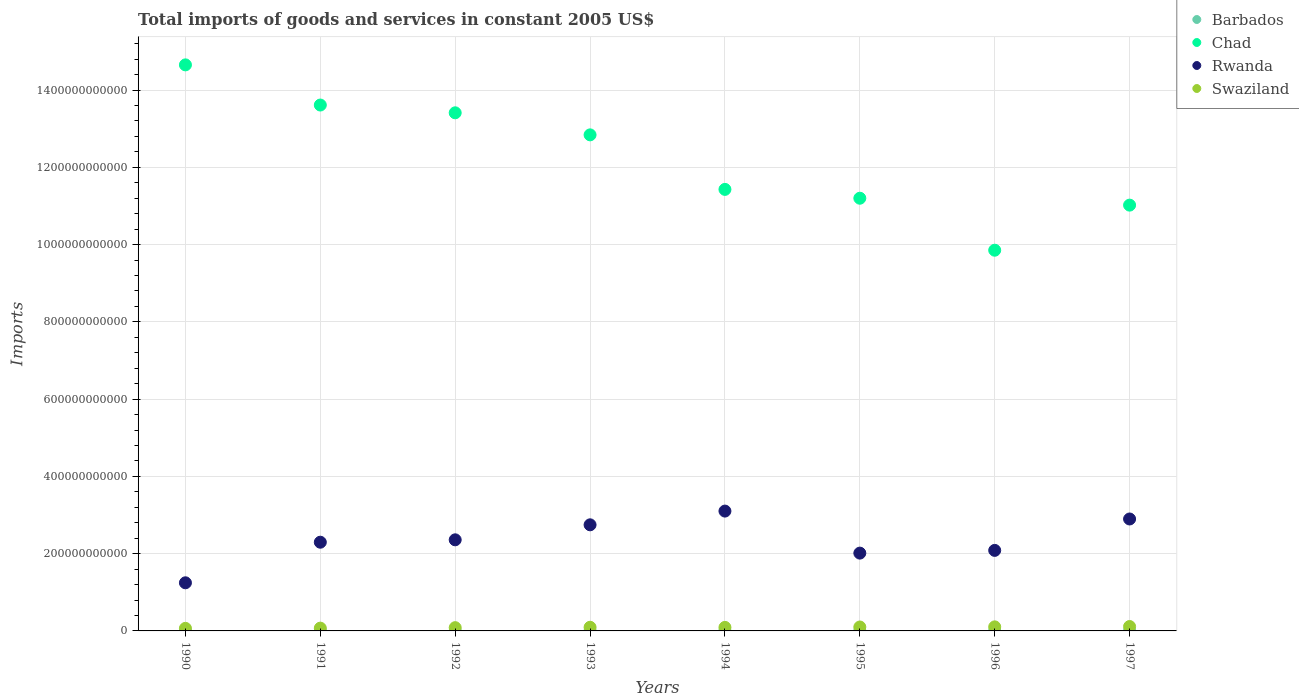Is the number of dotlines equal to the number of legend labels?
Provide a short and direct response. Yes. What is the total imports of goods and services in Chad in 1997?
Ensure brevity in your answer.  1.10e+12. Across all years, what is the maximum total imports of goods and services in Rwanda?
Your answer should be compact. 3.10e+11. Across all years, what is the minimum total imports of goods and services in Rwanda?
Your answer should be very brief. 1.25e+11. In which year was the total imports of goods and services in Chad minimum?
Provide a succinct answer. 1996. What is the total total imports of goods and services in Swaziland in the graph?
Offer a very short reply. 7.30e+1. What is the difference between the total imports of goods and services in Swaziland in 1996 and that in 1997?
Offer a very short reply. -8.96e+08. What is the difference between the total imports of goods and services in Barbados in 1993 and the total imports of goods and services in Swaziland in 1997?
Provide a succinct answer. -1.11e+1. What is the average total imports of goods and services in Swaziland per year?
Your answer should be compact. 9.13e+09. In the year 1991, what is the difference between the total imports of goods and services in Rwanda and total imports of goods and services in Swaziland?
Provide a succinct answer. 2.22e+11. What is the ratio of the total imports of goods and services in Rwanda in 1993 to that in 1995?
Make the answer very short. 1.36. Is the difference between the total imports of goods and services in Rwanda in 1994 and 1996 greater than the difference between the total imports of goods and services in Swaziland in 1994 and 1996?
Provide a succinct answer. Yes. What is the difference between the highest and the second highest total imports of goods and services in Rwanda?
Provide a succinct answer. 2.04e+1. What is the difference between the highest and the lowest total imports of goods and services in Rwanda?
Ensure brevity in your answer.  1.86e+11. In how many years, is the total imports of goods and services in Swaziland greater than the average total imports of goods and services in Swaziland taken over all years?
Keep it short and to the point. 5. Is the sum of the total imports of goods and services in Swaziland in 1993 and 1994 greater than the maximum total imports of goods and services in Rwanda across all years?
Provide a short and direct response. No. Is it the case that in every year, the sum of the total imports of goods and services in Chad and total imports of goods and services in Rwanda  is greater than the sum of total imports of goods and services in Swaziland and total imports of goods and services in Barbados?
Your answer should be compact. Yes. Is it the case that in every year, the sum of the total imports of goods and services in Rwanda and total imports of goods and services in Barbados  is greater than the total imports of goods and services in Swaziland?
Keep it short and to the point. Yes. Does the total imports of goods and services in Rwanda monotonically increase over the years?
Make the answer very short. No. Is the total imports of goods and services in Rwanda strictly greater than the total imports of goods and services in Chad over the years?
Keep it short and to the point. No. How many years are there in the graph?
Offer a terse response. 8. What is the difference between two consecutive major ticks on the Y-axis?
Make the answer very short. 2.00e+11. How many legend labels are there?
Ensure brevity in your answer.  4. What is the title of the graph?
Give a very brief answer. Total imports of goods and services in constant 2005 US$. What is the label or title of the Y-axis?
Provide a short and direct response. Imports. What is the Imports in Barbados in 1990?
Offer a very short reply. 3.87e+08. What is the Imports in Chad in 1990?
Your response must be concise. 1.47e+12. What is the Imports in Rwanda in 1990?
Keep it short and to the point. 1.25e+11. What is the Imports of Swaziland in 1990?
Your answer should be compact. 6.66e+09. What is the Imports in Barbados in 1991?
Your response must be concise. 5.10e+08. What is the Imports in Chad in 1991?
Your response must be concise. 1.36e+12. What is the Imports of Rwanda in 1991?
Ensure brevity in your answer.  2.30e+11. What is the Imports in Swaziland in 1991?
Offer a very short reply. 7.22e+09. What is the Imports of Barbados in 1992?
Offer a very short reply. 2.88e+08. What is the Imports of Chad in 1992?
Your answer should be compact. 1.34e+12. What is the Imports of Rwanda in 1992?
Keep it short and to the point. 2.36e+11. What is the Imports of Swaziland in 1992?
Give a very brief answer. 8.46e+09. What is the Imports of Barbados in 1993?
Your answer should be very brief. 3.28e+08. What is the Imports in Chad in 1993?
Provide a succinct answer. 1.28e+12. What is the Imports in Rwanda in 1993?
Keep it short and to the point. 2.75e+11. What is the Imports in Swaziland in 1993?
Provide a succinct answer. 9.45e+09. What is the Imports in Barbados in 1994?
Make the answer very short. 4.77e+08. What is the Imports in Chad in 1994?
Ensure brevity in your answer.  1.14e+12. What is the Imports of Rwanda in 1994?
Your answer should be compact. 3.10e+11. What is the Imports of Swaziland in 1994?
Your answer should be very brief. 9.14e+09. What is the Imports of Barbados in 1995?
Your answer should be very brief. 5.29e+08. What is the Imports in Chad in 1995?
Your response must be concise. 1.12e+12. What is the Imports of Rwanda in 1995?
Your response must be concise. 2.01e+11. What is the Imports in Swaziland in 1995?
Your answer should be very brief. 1.02e+1. What is the Imports in Barbados in 1996?
Make the answer very short. 5.50e+08. What is the Imports in Chad in 1996?
Your answer should be compact. 9.85e+11. What is the Imports in Rwanda in 1996?
Keep it short and to the point. 2.08e+11. What is the Imports of Swaziland in 1996?
Provide a succinct answer. 1.05e+1. What is the Imports in Barbados in 1997?
Offer a very short reply. 6.80e+08. What is the Imports of Chad in 1997?
Ensure brevity in your answer.  1.10e+12. What is the Imports of Rwanda in 1997?
Provide a short and direct response. 2.90e+11. What is the Imports in Swaziland in 1997?
Your answer should be very brief. 1.14e+1. Across all years, what is the maximum Imports of Barbados?
Ensure brevity in your answer.  6.80e+08. Across all years, what is the maximum Imports of Chad?
Your answer should be compact. 1.47e+12. Across all years, what is the maximum Imports of Rwanda?
Offer a terse response. 3.10e+11. Across all years, what is the maximum Imports of Swaziland?
Ensure brevity in your answer.  1.14e+1. Across all years, what is the minimum Imports of Barbados?
Provide a short and direct response. 2.88e+08. Across all years, what is the minimum Imports of Chad?
Offer a very short reply. 9.85e+11. Across all years, what is the minimum Imports in Rwanda?
Make the answer very short. 1.25e+11. Across all years, what is the minimum Imports in Swaziland?
Your answer should be very brief. 6.66e+09. What is the total Imports of Barbados in the graph?
Make the answer very short. 3.75e+09. What is the total Imports of Chad in the graph?
Give a very brief answer. 9.80e+12. What is the total Imports of Rwanda in the graph?
Your response must be concise. 1.87e+12. What is the total Imports of Swaziland in the graph?
Offer a terse response. 7.30e+1. What is the difference between the Imports of Barbados in 1990 and that in 1991?
Give a very brief answer. -1.23e+08. What is the difference between the Imports of Chad in 1990 and that in 1991?
Your answer should be very brief. 1.04e+11. What is the difference between the Imports in Rwanda in 1990 and that in 1991?
Offer a very short reply. -1.05e+11. What is the difference between the Imports in Swaziland in 1990 and that in 1991?
Offer a terse response. -5.66e+08. What is the difference between the Imports of Barbados in 1990 and that in 1992?
Give a very brief answer. 9.90e+07. What is the difference between the Imports of Chad in 1990 and that in 1992?
Make the answer very short. 1.24e+11. What is the difference between the Imports in Rwanda in 1990 and that in 1992?
Provide a short and direct response. -1.11e+11. What is the difference between the Imports in Swaziland in 1990 and that in 1992?
Your answer should be very brief. -1.80e+09. What is the difference between the Imports in Barbados in 1990 and that in 1993?
Provide a short and direct response. 5.90e+07. What is the difference between the Imports of Chad in 1990 and that in 1993?
Offer a very short reply. 1.81e+11. What is the difference between the Imports of Rwanda in 1990 and that in 1993?
Give a very brief answer. -1.50e+11. What is the difference between the Imports in Swaziland in 1990 and that in 1993?
Provide a short and direct response. -2.79e+09. What is the difference between the Imports in Barbados in 1990 and that in 1994?
Offer a terse response. -9.00e+07. What is the difference between the Imports of Chad in 1990 and that in 1994?
Keep it short and to the point. 3.22e+11. What is the difference between the Imports in Rwanda in 1990 and that in 1994?
Your answer should be compact. -1.86e+11. What is the difference between the Imports of Swaziland in 1990 and that in 1994?
Provide a short and direct response. -2.48e+09. What is the difference between the Imports of Barbados in 1990 and that in 1995?
Offer a terse response. -1.42e+08. What is the difference between the Imports in Chad in 1990 and that in 1995?
Offer a terse response. 3.45e+11. What is the difference between the Imports of Rwanda in 1990 and that in 1995?
Your answer should be very brief. -7.68e+1. What is the difference between the Imports of Swaziland in 1990 and that in 1995?
Provide a short and direct response. -3.50e+09. What is the difference between the Imports of Barbados in 1990 and that in 1996?
Keep it short and to the point. -1.63e+08. What is the difference between the Imports of Chad in 1990 and that in 1996?
Provide a short and direct response. 4.80e+11. What is the difference between the Imports in Rwanda in 1990 and that in 1996?
Provide a short and direct response. -8.39e+1. What is the difference between the Imports in Swaziland in 1990 and that in 1996?
Offer a very short reply. -3.86e+09. What is the difference between the Imports of Barbados in 1990 and that in 1997?
Your answer should be compact. -2.93e+08. What is the difference between the Imports of Chad in 1990 and that in 1997?
Keep it short and to the point. 3.63e+11. What is the difference between the Imports of Rwanda in 1990 and that in 1997?
Provide a short and direct response. -1.65e+11. What is the difference between the Imports in Swaziland in 1990 and that in 1997?
Provide a succinct answer. -4.75e+09. What is the difference between the Imports in Barbados in 1991 and that in 1992?
Provide a short and direct response. 2.22e+08. What is the difference between the Imports of Chad in 1991 and that in 1992?
Your answer should be very brief. 2.01e+1. What is the difference between the Imports of Rwanda in 1991 and that in 1992?
Your answer should be compact. -6.20e+09. What is the difference between the Imports of Swaziland in 1991 and that in 1992?
Offer a terse response. -1.23e+09. What is the difference between the Imports of Barbados in 1991 and that in 1993?
Ensure brevity in your answer.  1.82e+08. What is the difference between the Imports in Chad in 1991 and that in 1993?
Your response must be concise. 7.72e+1. What is the difference between the Imports of Rwanda in 1991 and that in 1993?
Make the answer very short. -4.50e+1. What is the difference between the Imports in Swaziland in 1991 and that in 1993?
Give a very brief answer. -2.22e+09. What is the difference between the Imports of Barbados in 1991 and that in 1994?
Your response must be concise. 3.30e+07. What is the difference between the Imports of Chad in 1991 and that in 1994?
Ensure brevity in your answer.  2.18e+11. What is the difference between the Imports of Rwanda in 1991 and that in 1994?
Your response must be concise. -8.06e+1. What is the difference between the Imports of Swaziland in 1991 and that in 1994?
Offer a very short reply. -1.92e+09. What is the difference between the Imports of Barbados in 1991 and that in 1995?
Offer a very short reply. -1.90e+07. What is the difference between the Imports of Chad in 1991 and that in 1995?
Provide a short and direct response. 2.41e+11. What is the difference between the Imports of Rwanda in 1991 and that in 1995?
Your answer should be very brief. 2.82e+1. What is the difference between the Imports of Swaziland in 1991 and that in 1995?
Your answer should be very brief. -2.94e+09. What is the difference between the Imports in Barbados in 1991 and that in 1996?
Offer a very short reply. -4.00e+07. What is the difference between the Imports in Chad in 1991 and that in 1996?
Your answer should be very brief. 3.76e+11. What is the difference between the Imports of Rwanda in 1991 and that in 1996?
Provide a short and direct response. 2.12e+1. What is the difference between the Imports of Swaziland in 1991 and that in 1996?
Give a very brief answer. -3.29e+09. What is the difference between the Imports of Barbados in 1991 and that in 1997?
Offer a very short reply. -1.70e+08. What is the difference between the Imports of Chad in 1991 and that in 1997?
Provide a succinct answer. 2.59e+11. What is the difference between the Imports in Rwanda in 1991 and that in 1997?
Your response must be concise. -6.01e+1. What is the difference between the Imports of Swaziland in 1991 and that in 1997?
Provide a short and direct response. -4.19e+09. What is the difference between the Imports in Barbados in 1992 and that in 1993?
Your response must be concise. -4.00e+07. What is the difference between the Imports in Chad in 1992 and that in 1993?
Keep it short and to the point. 5.71e+1. What is the difference between the Imports in Rwanda in 1992 and that in 1993?
Keep it short and to the point. -3.88e+1. What is the difference between the Imports in Swaziland in 1992 and that in 1993?
Offer a terse response. -9.92e+08. What is the difference between the Imports in Barbados in 1992 and that in 1994?
Your answer should be very brief. -1.89e+08. What is the difference between the Imports of Chad in 1992 and that in 1994?
Offer a very short reply. 1.98e+11. What is the difference between the Imports of Rwanda in 1992 and that in 1994?
Your response must be concise. -7.44e+1. What is the difference between the Imports in Swaziland in 1992 and that in 1994?
Make the answer very short. -6.85e+08. What is the difference between the Imports of Barbados in 1992 and that in 1995?
Offer a very short reply. -2.41e+08. What is the difference between the Imports in Chad in 1992 and that in 1995?
Keep it short and to the point. 2.21e+11. What is the difference between the Imports in Rwanda in 1992 and that in 1995?
Your answer should be very brief. 3.44e+1. What is the difference between the Imports of Swaziland in 1992 and that in 1995?
Make the answer very short. -1.70e+09. What is the difference between the Imports in Barbados in 1992 and that in 1996?
Provide a succinct answer. -2.62e+08. What is the difference between the Imports of Chad in 1992 and that in 1996?
Make the answer very short. 3.56e+11. What is the difference between the Imports of Rwanda in 1992 and that in 1996?
Keep it short and to the point. 2.74e+1. What is the difference between the Imports of Swaziland in 1992 and that in 1996?
Provide a succinct answer. -2.06e+09. What is the difference between the Imports in Barbados in 1992 and that in 1997?
Keep it short and to the point. -3.92e+08. What is the difference between the Imports of Chad in 1992 and that in 1997?
Provide a short and direct response. 2.39e+11. What is the difference between the Imports in Rwanda in 1992 and that in 1997?
Offer a very short reply. -5.39e+1. What is the difference between the Imports in Swaziland in 1992 and that in 1997?
Make the answer very short. -2.95e+09. What is the difference between the Imports of Barbados in 1993 and that in 1994?
Give a very brief answer. -1.49e+08. What is the difference between the Imports of Chad in 1993 and that in 1994?
Your response must be concise. 1.41e+11. What is the difference between the Imports in Rwanda in 1993 and that in 1994?
Provide a short and direct response. -3.55e+1. What is the difference between the Imports of Swaziland in 1993 and that in 1994?
Give a very brief answer. 3.07e+08. What is the difference between the Imports in Barbados in 1993 and that in 1995?
Ensure brevity in your answer.  -2.01e+08. What is the difference between the Imports of Chad in 1993 and that in 1995?
Offer a terse response. 1.64e+11. What is the difference between the Imports of Rwanda in 1993 and that in 1995?
Offer a very short reply. 7.32e+1. What is the difference between the Imports of Swaziland in 1993 and that in 1995?
Your response must be concise. -7.13e+08. What is the difference between the Imports of Barbados in 1993 and that in 1996?
Keep it short and to the point. -2.22e+08. What is the difference between the Imports in Chad in 1993 and that in 1996?
Offer a terse response. 2.99e+11. What is the difference between the Imports in Rwanda in 1993 and that in 1996?
Provide a succinct answer. 6.62e+1. What is the difference between the Imports of Swaziland in 1993 and that in 1996?
Offer a very short reply. -1.07e+09. What is the difference between the Imports of Barbados in 1993 and that in 1997?
Ensure brevity in your answer.  -3.52e+08. What is the difference between the Imports in Chad in 1993 and that in 1997?
Ensure brevity in your answer.  1.82e+11. What is the difference between the Imports in Rwanda in 1993 and that in 1997?
Ensure brevity in your answer.  -1.51e+1. What is the difference between the Imports of Swaziland in 1993 and that in 1997?
Provide a short and direct response. -1.96e+09. What is the difference between the Imports of Barbados in 1994 and that in 1995?
Your response must be concise. -5.20e+07. What is the difference between the Imports of Chad in 1994 and that in 1995?
Your answer should be compact. 2.29e+1. What is the difference between the Imports in Rwanda in 1994 and that in 1995?
Keep it short and to the point. 1.09e+11. What is the difference between the Imports in Swaziland in 1994 and that in 1995?
Your answer should be very brief. -1.02e+09. What is the difference between the Imports in Barbados in 1994 and that in 1996?
Your answer should be compact. -7.30e+07. What is the difference between the Imports in Chad in 1994 and that in 1996?
Provide a succinct answer. 1.57e+11. What is the difference between the Imports in Rwanda in 1994 and that in 1996?
Ensure brevity in your answer.  1.02e+11. What is the difference between the Imports in Swaziland in 1994 and that in 1996?
Give a very brief answer. -1.37e+09. What is the difference between the Imports in Barbados in 1994 and that in 1997?
Your answer should be compact. -2.03e+08. What is the difference between the Imports of Chad in 1994 and that in 1997?
Provide a short and direct response. 4.07e+1. What is the difference between the Imports in Rwanda in 1994 and that in 1997?
Your answer should be very brief. 2.04e+1. What is the difference between the Imports of Swaziland in 1994 and that in 1997?
Your response must be concise. -2.27e+09. What is the difference between the Imports of Barbados in 1995 and that in 1996?
Your answer should be very brief. -2.10e+07. What is the difference between the Imports in Chad in 1995 and that in 1996?
Your answer should be very brief. 1.35e+11. What is the difference between the Imports in Rwanda in 1995 and that in 1996?
Make the answer very short. -7.05e+09. What is the difference between the Imports in Swaziland in 1995 and that in 1996?
Your answer should be compact. -3.54e+08. What is the difference between the Imports in Barbados in 1995 and that in 1997?
Provide a succinct answer. -1.51e+08. What is the difference between the Imports in Chad in 1995 and that in 1997?
Keep it short and to the point. 1.79e+1. What is the difference between the Imports in Rwanda in 1995 and that in 1997?
Your response must be concise. -8.84e+1. What is the difference between the Imports of Swaziland in 1995 and that in 1997?
Make the answer very short. -1.25e+09. What is the difference between the Imports of Barbados in 1996 and that in 1997?
Your response must be concise. -1.30e+08. What is the difference between the Imports in Chad in 1996 and that in 1997?
Offer a very short reply. -1.17e+11. What is the difference between the Imports of Rwanda in 1996 and that in 1997?
Ensure brevity in your answer.  -8.13e+1. What is the difference between the Imports in Swaziland in 1996 and that in 1997?
Offer a terse response. -8.96e+08. What is the difference between the Imports in Barbados in 1990 and the Imports in Chad in 1991?
Offer a terse response. -1.36e+12. What is the difference between the Imports of Barbados in 1990 and the Imports of Rwanda in 1991?
Offer a terse response. -2.29e+11. What is the difference between the Imports in Barbados in 1990 and the Imports in Swaziland in 1991?
Your answer should be compact. -6.84e+09. What is the difference between the Imports in Chad in 1990 and the Imports in Rwanda in 1991?
Offer a very short reply. 1.24e+12. What is the difference between the Imports of Chad in 1990 and the Imports of Swaziland in 1991?
Give a very brief answer. 1.46e+12. What is the difference between the Imports of Rwanda in 1990 and the Imports of Swaziland in 1991?
Give a very brief answer. 1.17e+11. What is the difference between the Imports of Barbados in 1990 and the Imports of Chad in 1992?
Offer a very short reply. -1.34e+12. What is the difference between the Imports in Barbados in 1990 and the Imports in Rwanda in 1992?
Make the answer very short. -2.35e+11. What is the difference between the Imports in Barbados in 1990 and the Imports in Swaziland in 1992?
Provide a succinct answer. -8.07e+09. What is the difference between the Imports in Chad in 1990 and the Imports in Rwanda in 1992?
Your answer should be very brief. 1.23e+12. What is the difference between the Imports of Chad in 1990 and the Imports of Swaziland in 1992?
Offer a terse response. 1.46e+12. What is the difference between the Imports in Rwanda in 1990 and the Imports in Swaziland in 1992?
Make the answer very short. 1.16e+11. What is the difference between the Imports of Barbados in 1990 and the Imports of Chad in 1993?
Offer a terse response. -1.28e+12. What is the difference between the Imports of Barbados in 1990 and the Imports of Rwanda in 1993?
Your response must be concise. -2.74e+11. What is the difference between the Imports in Barbados in 1990 and the Imports in Swaziland in 1993?
Provide a succinct answer. -9.06e+09. What is the difference between the Imports in Chad in 1990 and the Imports in Rwanda in 1993?
Offer a very short reply. 1.19e+12. What is the difference between the Imports of Chad in 1990 and the Imports of Swaziland in 1993?
Offer a very short reply. 1.46e+12. What is the difference between the Imports in Rwanda in 1990 and the Imports in Swaziland in 1993?
Your answer should be very brief. 1.15e+11. What is the difference between the Imports of Barbados in 1990 and the Imports of Chad in 1994?
Provide a succinct answer. -1.14e+12. What is the difference between the Imports of Barbados in 1990 and the Imports of Rwanda in 1994?
Ensure brevity in your answer.  -3.10e+11. What is the difference between the Imports in Barbados in 1990 and the Imports in Swaziland in 1994?
Your answer should be very brief. -8.75e+09. What is the difference between the Imports of Chad in 1990 and the Imports of Rwanda in 1994?
Offer a terse response. 1.16e+12. What is the difference between the Imports of Chad in 1990 and the Imports of Swaziland in 1994?
Make the answer very short. 1.46e+12. What is the difference between the Imports of Rwanda in 1990 and the Imports of Swaziland in 1994?
Your answer should be compact. 1.15e+11. What is the difference between the Imports in Barbados in 1990 and the Imports in Chad in 1995?
Your response must be concise. -1.12e+12. What is the difference between the Imports of Barbados in 1990 and the Imports of Rwanda in 1995?
Ensure brevity in your answer.  -2.01e+11. What is the difference between the Imports in Barbados in 1990 and the Imports in Swaziland in 1995?
Give a very brief answer. -9.77e+09. What is the difference between the Imports of Chad in 1990 and the Imports of Rwanda in 1995?
Provide a short and direct response. 1.26e+12. What is the difference between the Imports of Chad in 1990 and the Imports of Swaziland in 1995?
Provide a short and direct response. 1.46e+12. What is the difference between the Imports of Rwanda in 1990 and the Imports of Swaziland in 1995?
Your response must be concise. 1.14e+11. What is the difference between the Imports of Barbados in 1990 and the Imports of Chad in 1996?
Ensure brevity in your answer.  -9.85e+11. What is the difference between the Imports in Barbados in 1990 and the Imports in Rwanda in 1996?
Provide a short and direct response. -2.08e+11. What is the difference between the Imports of Barbados in 1990 and the Imports of Swaziland in 1996?
Make the answer very short. -1.01e+1. What is the difference between the Imports of Chad in 1990 and the Imports of Rwanda in 1996?
Ensure brevity in your answer.  1.26e+12. What is the difference between the Imports of Chad in 1990 and the Imports of Swaziland in 1996?
Your answer should be compact. 1.45e+12. What is the difference between the Imports in Rwanda in 1990 and the Imports in Swaziland in 1996?
Ensure brevity in your answer.  1.14e+11. What is the difference between the Imports in Barbados in 1990 and the Imports in Chad in 1997?
Keep it short and to the point. -1.10e+12. What is the difference between the Imports of Barbados in 1990 and the Imports of Rwanda in 1997?
Your answer should be very brief. -2.89e+11. What is the difference between the Imports in Barbados in 1990 and the Imports in Swaziland in 1997?
Provide a succinct answer. -1.10e+1. What is the difference between the Imports in Chad in 1990 and the Imports in Rwanda in 1997?
Offer a very short reply. 1.18e+12. What is the difference between the Imports in Chad in 1990 and the Imports in Swaziland in 1997?
Ensure brevity in your answer.  1.45e+12. What is the difference between the Imports in Rwanda in 1990 and the Imports in Swaziland in 1997?
Give a very brief answer. 1.13e+11. What is the difference between the Imports of Barbados in 1991 and the Imports of Chad in 1992?
Make the answer very short. -1.34e+12. What is the difference between the Imports of Barbados in 1991 and the Imports of Rwanda in 1992?
Keep it short and to the point. -2.35e+11. What is the difference between the Imports in Barbados in 1991 and the Imports in Swaziland in 1992?
Your answer should be very brief. -7.95e+09. What is the difference between the Imports in Chad in 1991 and the Imports in Rwanda in 1992?
Offer a very short reply. 1.13e+12. What is the difference between the Imports of Chad in 1991 and the Imports of Swaziland in 1992?
Make the answer very short. 1.35e+12. What is the difference between the Imports of Rwanda in 1991 and the Imports of Swaziland in 1992?
Offer a very short reply. 2.21e+11. What is the difference between the Imports in Barbados in 1991 and the Imports in Chad in 1993?
Your answer should be very brief. -1.28e+12. What is the difference between the Imports of Barbados in 1991 and the Imports of Rwanda in 1993?
Your response must be concise. -2.74e+11. What is the difference between the Imports of Barbados in 1991 and the Imports of Swaziland in 1993?
Ensure brevity in your answer.  -8.94e+09. What is the difference between the Imports in Chad in 1991 and the Imports in Rwanda in 1993?
Make the answer very short. 1.09e+12. What is the difference between the Imports in Chad in 1991 and the Imports in Swaziland in 1993?
Offer a very short reply. 1.35e+12. What is the difference between the Imports in Rwanda in 1991 and the Imports in Swaziland in 1993?
Offer a very short reply. 2.20e+11. What is the difference between the Imports in Barbados in 1991 and the Imports in Chad in 1994?
Make the answer very short. -1.14e+12. What is the difference between the Imports in Barbados in 1991 and the Imports in Rwanda in 1994?
Offer a terse response. -3.10e+11. What is the difference between the Imports in Barbados in 1991 and the Imports in Swaziland in 1994?
Provide a short and direct response. -8.63e+09. What is the difference between the Imports in Chad in 1991 and the Imports in Rwanda in 1994?
Provide a succinct answer. 1.05e+12. What is the difference between the Imports of Chad in 1991 and the Imports of Swaziland in 1994?
Offer a very short reply. 1.35e+12. What is the difference between the Imports in Rwanda in 1991 and the Imports in Swaziland in 1994?
Make the answer very short. 2.20e+11. What is the difference between the Imports in Barbados in 1991 and the Imports in Chad in 1995?
Make the answer very short. -1.12e+12. What is the difference between the Imports of Barbados in 1991 and the Imports of Rwanda in 1995?
Keep it short and to the point. -2.01e+11. What is the difference between the Imports in Barbados in 1991 and the Imports in Swaziland in 1995?
Provide a short and direct response. -9.65e+09. What is the difference between the Imports of Chad in 1991 and the Imports of Rwanda in 1995?
Your answer should be compact. 1.16e+12. What is the difference between the Imports of Chad in 1991 and the Imports of Swaziland in 1995?
Your answer should be compact. 1.35e+12. What is the difference between the Imports in Rwanda in 1991 and the Imports in Swaziland in 1995?
Make the answer very short. 2.19e+11. What is the difference between the Imports of Barbados in 1991 and the Imports of Chad in 1996?
Keep it short and to the point. -9.85e+11. What is the difference between the Imports of Barbados in 1991 and the Imports of Rwanda in 1996?
Provide a succinct answer. -2.08e+11. What is the difference between the Imports in Barbados in 1991 and the Imports in Swaziland in 1996?
Make the answer very short. -1.00e+1. What is the difference between the Imports of Chad in 1991 and the Imports of Rwanda in 1996?
Provide a succinct answer. 1.15e+12. What is the difference between the Imports in Chad in 1991 and the Imports in Swaziland in 1996?
Your answer should be compact. 1.35e+12. What is the difference between the Imports of Rwanda in 1991 and the Imports of Swaziland in 1996?
Offer a very short reply. 2.19e+11. What is the difference between the Imports of Barbados in 1991 and the Imports of Chad in 1997?
Provide a succinct answer. -1.10e+12. What is the difference between the Imports in Barbados in 1991 and the Imports in Rwanda in 1997?
Your answer should be compact. -2.89e+11. What is the difference between the Imports of Barbados in 1991 and the Imports of Swaziland in 1997?
Keep it short and to the point. -1.09e+1. What is the difference between the Imports of Chad in 1991 and the Imports of Rwanda in 1997?
Provide a short and direct response. 1.07e+12. What is the difference between the Imports in Chad in 1991 and the Imports in Swaziland in 1997?
Provide a short and direct response. 1.35e+12. What is the difference between the Imports in Rwanda in 1991 and the Imports in Swaziland in 1997?
Your answer should be very brief. 2.18e+11. What is the difference between the Imports of Barbados in 1992 and the Imports of Chad in 1993?
Your answer should be compact. -1.28e+12. What is the difference between the Imports of Barbados in 1992 and the Imports of Rwanda in 1993?
Provide a short and direct response. -2.74e+11. What is the difference between the Imports in Barbados in 1992 and the Imports in Swaziland in 1993?
Provide a short and direct response. -9.16e+09. What is the difference between the Imports of Chad in 1992 and the Imports of Rwanda in 1993?
Provide a succinct answer. 1.07e+12. What is the difference between the Imports in Chad in 1992 and the Imports in Swaziland in 1993?
Ensure brevity in your answer.  1.33e+12. What is the difference between the Imports in Rwanda in 1992 and the Imports in Swaziland in 1993?
Provide a short and direct response. 2.26e+11. What is the difference between the Imports in Barbados in 1992 and the Imports in Chad in 1994?
Keep it short and to the point. -1.14e+12. What is the difference between the Imports of Barbados in 1992 and the Imports of Rwanda in 1994?
Your answer should be compact. -3.10e+11. What is the difference between the Imports in Barbados in 1992 and the Imports in Swaziland in 1994?
Provide a succinct answer. -8.85e+09. What is the difference between the Imports of Chad in 1992 and the Imports of Rwanda in 1994?
Your answer should be compact. 1.03e+12. What is the difference between the Imports of Chad in 1992 and the Imports of Swaziland in 1994?
Provide a short and direct response. 1.33e+12. What is the difference between the Imports in Rwanda in 1992 and the Imports in Swaziland in 1994?
Your response must be concise. 2.27e+11. What is the difference between the Imports in Barbados in 1992 and the Imports in Chad in 1995?
Provide a short and direct response. -1.12e+12. What is the difference between the Imports of Barbados in 1992 and the Imports of Rwanda in 1995?
Offer a very short reply. -2.01e+11. What is the difference between the Imports in Barbados in 1992 and the Imports in Swaziland in 1995?
Keep it short and to the point. -9.87e+09. What is the difference between the Imports in Chad in 1992 and the Imports in Rwanda in 1995?
Provide a short and direct response. 1.14e+12. What is the difference between the Imports of Chad in 1992 and the Imports of Swaziland in 1995?
Your answer should be very brief. 1.33e+12. What is the difference between the Imports in Rwanda in 1992 and the Imports in Swaziland in 1995?
Keep it short and to the point. 2.26e+11. What is the difference between the Imports in Barbados in 1992 and the Imports in Chad in 1996?
Keep it short and to the point. -9.85e+11. What is the difference between the Imports in Barbados in 1992 and the Imports in Rwanda in 1996?
Provide a short and direct response. -2.08e+11. What is the difference between the Imports in Barbados in 1992 and the Imports in Swaziland in 1996?
Keep it short and to the point. -1.02e+1. What is the difference between the Imports of Chad in 1992 and the Imports of Rwanda in 1996?
Ensure brevity in your answer.  1.13e+12. What is the difference between the Imports in Chad in 1992 and the Imports in Swaziland in 1996?
Provide a succinct answer. 1.33e+12. What is the difference between the Imports in Rwanda in 1992 and the Imports in Swaziland in 1996?
Offer a very short reply. 2.25e+11. What is the difference between the Imports in Barbados in 1992 and the Imports in Chad in 1997?
Your answer should be very brief. -1.10e+12. What is the difference between the Imports in Barbados in 1992 and the Imports in Rwanda in 1997?
Your answer should be compact. -2.89e+11. What is the difference between the Imports of Barbados in 1992 and the Imports of Swaziland in 1997?
Provide a short and direct response. -1.11e+1. What is the difference between the Imports of Chad in 1992 and the Imports of Rwanda in 1997?
Keep it short and to the point. 1.05e+12. What is the difference between the Imports in Chad in 1992 and the Imports in Swaziland in 1997?
Offer a very short reply. 1.33e+12. What is the difference between the Imports in Rwanda in 1992 and the Imports in Swaziland in 1997?
Ensure brevity in your answer.  2.24e+11. What is the difference between the Imports of Barbados in 1993 and the Imports of Chad in 1994?
Make the answer very short. -1.14e+12. What is the difference between the Imports of Barbados in 1993 and the Imports of Rwanda in 1994?
Provide a short and direct response. -3.10e+11. What is the difference between the Imports of Barbados in 1993 and the Imports of Swaziland in 1994?
Your answer should be compact. -8.81e+09. What is the difference between the Imports of Chad in 1993 and the Imports of Rwanda in 1994?
Provide a short and direct response. 9.74e+11. What is the difference between the Imports in Chad in 1993 and the Imports in Swaziland in 1994?
Your answer should be very brief. 1.27e+12. What is the difference between the Imports in Rwanda in 1993 and the Imports in Swaziland in 1994?
Give a very brief answer. 2.66e+11. What is the difference between the Imports in Barbados in 1993 and the Imports in Chad in 1995?
Give a very brief answer. -1.12e+12. What is the difference between the Imports of Barbados in 1993 and the Imports of Rwanda in 1995?
Ensure brevity in your answer.  -2.01e+11. What is the difference between the Imports of Barbados in 1993 and the Imports of Swaziland in 1995?
Your answer should be compact. -9.83e+09. What is the difference between the Imports in Chad in 1993 and the Imports in Rwanda in 1995?
Provide a succinct answer. 1.08e+12. What is the difference between the Imports of Chad in 1993 and the Imports of Swaziland in 1995?
Provide a short and direct response. 1.27e+12. What is the difference between the Imports of Rwanda in 1993 and the Imports of Swaziland in 1995?
Give a very brief answer. 2.64e+11. What is the difference between the Imports in Barbados in 1993 and the Imports in Chad in 1996?
Provide a succinct answer. -9.85e+11. What is the difference between the Imports in Barbados in 1993 and the Imports in Rwanda in 1996?
Offer a terse response. -2.08e+11. What is the difference between the Imports of Barbados in 1993 and the Imports of Swaziland in 1996?
Provide a short and direct response. -1.02e+1. What is the difference between the Imports of Chad in 1993 and the Imports of Rwanda in 1996?
Provide a short and direct response. 1.08e+12. What is the difference between the Imports in Chad in 1993 and the Imports in Swaziland in 1996?
Keep it short and to the point. 1.27e+12. What is the difference between the Imports in Rwanda in 1993 and the Imports in Swaziland in 1996?
Your response must be concise. 2.64e+11. What is the difference between the Imports of Barbados in 1993 and the Imports of Chad in 1997?
Your answer should be very brief. -1.10e+12. What is the difference between the Imports in Barbados in 1993 and the Imports in Rwanda in 1997?
Make the answer very short. -2.89e+11. What is the difference between the Imports of Barbados in 1993 and the Imports of Swaziland in 1997?
Provide a short and direct response. -1.11e+1. What is the difference between the Imports in Chad in 1993 and the Imports in Rwanda in 1997?
Provide a short and direct response. 9.94e+11. What is the difference between the Imports in Chad in 1993 and the Imports in Swaziland in 1997?
Provide a short and direct response. 1.27e+12. What is the difference between the Imports in Rwanda in 1993 and the Imports in Swaziland in 1997?
Give a very brief answer. 2.63e+11. What is the difference between the Imports in Barbados in 1994 and the Imports in Chad in 1995?
Keep it short and to the point. -1.12e+12. What is the difference between the Imports of Barbados in 1994 and the Imports of Rwanda in 1995?
Give a very brief answer. -2.01e+11. What is the difference between the Imports of Barbados in 1994 and the Imports of Swaziland in 1995?
Your answer should be very brief. -9.68e+09. What is the difference between the Imports in Chad in 1994 and the Imports in Rwanda in 1995?
Keep it short and to the point. 9.42e+11. What is the difference between the Imports in Chad in 1994 and the Imports in Swaziland in 1995?
Ensure brevity in your answer.  1.13e+12. What is the difference between the Imports in Rwanda in 1994 and the Imports in Swaziland in 1995?
Offer a terse response. 3.00e+11. What is the difference between the Imports of Barbados in 1994 and the Imports of Chad in 1996?
Offer a terse response. -9.85e+11. What is the difference between the Imports in Barbados in 1994 and the Imports in Rwanda in 1996?
Offer a very short reply. -2.08e+11. What is the difference between the Imports of Barbados in 1994 and the Imports of Swaziland in 1996?
Offer a very short reply. -1.00e+1. What is the difference between the Imports in Chad in 1994 and the Imports in Rwanda in 1996?
Your answer should be very brief. 9.34e+11. What is the difference between the Imports of Chad in 1994 and the Imports of Swaziland in 1996?
Ensure brevity in your answer.  1.13e+12. What is the difference between the Imports of Rwanda in 1994 and the Imports of Swaziland in 1996?
Provide a succinct answer. 3.00e+11. What is the difference between the Imports in Barbados in 1994 and the Imports in Chad in 1997?
Your answer should be very brief. -1.10e+12. What is the difference between the Imports in Barbados in 1994 and the Imports in Rwanda in 1997?
Make the answer very short. -2.89e+11. What is the difference between the Imports of Barbados in 1994 and the Imports of Swaziland in 1997?
Provide a succinct answer. -1.09e+1. What is the difference between the Imports of Chad in 1994 and the Imports of Rwanda in 1997?
Give a very brief answer. 8.53e+11. What is the difference between the Imports in Chad in 1994 and the Imports in Swaziland in 1997?
Your answer should be compact. 1.13e+12. What is the difference between the Imports of Rwanda in 1994 and the Imports of Swaziland in 1997?
Keep it short and to the point. 2.99e+11. What is the difference between the Imports of Barbados in 1995 and the Imports of Chad in 1996?
Provide a succinct answer. -9.85e+11. What is the difference between the Imports in Barbados in 1995 and the Imports in Rwanda in 1996?
Your answer should be very brief. -2.08e+11. What is the difference between the Imports of Barbados in 1995 and the Imports of Swaziland in 1996?
Give a very brief answer. -9.99e+09. What is the difference between the Imports of Chad in 1995 and the Imports of Rwanda in 1996?
Your answer should be compact. 9.12e+11. What is the difference between the Imports of Chad in 1995 and the Imports of Swaziland in 1996?
Provide a short and direct response. 1.11e+12. What is the difference between the Imports in Rwanda in 1995 and the Imports in Swaziland in 1996?
Your answer should be very brief. 1.91e+11. What is the difference between the Imports of Barbados in 1995 and the Imports of Chad in 1997?
Offer a terse response. -1.10e+12. What is the difference between the Imports in Barbados in 1995 and the Imports in Rwanda in 1997?
Ensure brevity in your answer.  -2.89e+11. What is the difference between the Imports in Barbados in 1995 and the Imports in Swaziland in 1997?
Your answer should be very brief. -1.09e+1. What is the difference between the Imports of Chad in 1995 and the Imports of Rwanda in 1997?
Your response must be concise. 8.30e+11. What is the difference between the Imports of Chad in 1995 and the Imports of Swaziland in 1997?
Make the answer very short. 1.11e+12. What is the difference between the Imports in Rwanda in 1995 and the Imports in Swaziland in 1997?
Provide a succinct answer. 1.90e+11. What is the difference between the Imports in Barbados in 1996 and the Imports in Chad in 1997?
Offer a terse response. -1.10e+12. What is the difference between the Imports in Barbados in 1996 and the Imports in Rwanda in 1997?
Your response must be concise. -2.89e+11. What is the difference between the Imports of Barbados in 1996 and the Imports of Swaziland in 1997?
Your answer should be compact. -1.09e+1. What is the difference between the Imports of Chad in 1996 and the Imports of Rwanda in 1997?
Keep it short and to the point. 6.96e+11. What is the difference between the Imports of Chad in 1996 and the Imports of Swaziland in 1997?
Keep it short and to the point. 9.74e+11. What is the difference between the Imports in Rwanda in 1996 and the Imports in Swaziland in 1997?
Offer a terse response. 1.97e+11. What is the average Imports in Barbados per year?
Ensure brevity in your answer.  4.69e+08. What is the average Imports of Chad per year?
Your answer should be compact. 1.23e+12. What is the average Imports in Rwanda per year?
Make the answer very short. 2.34e+11. What is the average Imports of Swaziland per year?
Your response must be concise. 9.13e+09. In the year 1990, what is the difference between the Imports in Barbados and Imports in Chad?
Give a very brief answer. -1.46e+12. In the year 1990, what is the difference between the Imports in Barbados and Imports in Rwanda?
Offer a very short reply. -1.24e+11. In the year 1990, what is the difference between the Imports of Barbados and Imports of Swaziland?
Make the answer very short. -6.27e+09. In the year 1990, what is the difference between the Imports of Chad and Imports of Rwanda?
Ensure brevity in your answer.  1.34e+12. In the year 1990, what is the difference between the Imports of Chad and Imports of Swaziland?
Make the answer very short. 1.46e+12. In the year 1990, what is the difference between the Imports of Rwanda and Imports of Swaziland?
Give a very brief answer. 1.18e+11. In the year 1991, what is the difference between the Imports of Barbados and Imports of Chad?
Make the answer very short. -1.36e+12. In the year 1991, what is the difference between the Imports in Barbados and Imports in Rwanda?
Keep it short and to the point. -2.29e+11. In the year 1991, what is the difference between the Imports in Barbados and Imports in Swaziland?
Offer a very short reply. -6.71e+09. In the year 1991, what is the difference between the Imports in Chad and Imports in Rwanda?
Offer a very short reply. 1.13e+12. In the year 1991, what is the difference between the Imports in Chad and Imports in Swaziland?
Provide a short and direct response. 1.35e+12. In the year 1991, what is the difference between the Imports of Rwanda and Imports of Swaziland?
Provide a short and direct response. 2.22e+11. In the year 1992, what is the difference between the Imports of Barbados and Imports of Chad?
Offer a very short reply. -1.34e+12. In the year 1992, what is the difference between the Imports of Barbados and Imports of Rwanda?
Provide a short and direct response. -2.36e+11. In the year 1992, what is the difference between the Imports in Barbados and Imports in Swaziland?
Give a very brief answer. -8.17e+09. In the year 1992, what is the difference between the Imports of Chad and Imports of Rwanda?
Offer a very short reply. 1.11e+12. In the year 1992, what is the difference between the Imports of Chad and Imports of Swaziland?
Offer a terse response. 1.33e+12. In the year 1992, what is the difference between the Imports in Rwanda and Imports in Swaziland?
Your response must be concise. 2.27e+11. In the year 1993, what is the difference between the Imports of Barbados and Imports of Chad?
Keep it short and to the point. -1.28e+12. In the year 1993, what is the difference between the Imports in Barbados and Imports in Rwanda?
Your answer should be very brief. -2.74e+11. In the year 1993, what is the difference between the Imports of Barbados and Imports of Swaziland?
Your answer should be very brief. -9.12e+09. In the year 1993, what is the difference between the Imports of Chad and Imports of Rwanda?
Your response must be concise. 1.01e+12. In the year 1993, what is the difference between the Imports of Chad and Imports of Swaziland?
Offer a very short reply. 1.27e+12. In the year 1993, what is the difference between the Imports in Rwanda and Imports in Swaziland?
Give a very brief answer. 2.65e+11. In the year 1994, what is the difference between the Imports in Barbados and Imports in Chad?
Your answer should be very brief. -1.14e+12. In the year 1994, what is the difference between the Imports of Barbados and Imports of Rwanda?
Keep it short and to the point. -3.10e+11. In the year 1994, what is the difference between the Imports in Barbados and Imports in Swaziland?
Provide a succinct answer. -8.66e+09. In the year 1994, what is the difference between the Imports in Chad and Imports in Rwanda?
Make the answer very short. 8.33e+11. In the year 1994, what is the difference between the Imports of Chad and Imports of Swaziland?
Keep it short and to the point. 1.13e+12. In the year 1994, what is the difference between the Imports of Rwanda and Imports of Swaziland?
Offer a very short reply. 3.01e+11. In the year 1995, what is the difference between the Imports of Barbados and Imports of Chad?
Make the answer very short. -1.12e+12. In the year 1995, what is the difference between the Imports of Barbados and Imports of Rwanda?
Keep it short and to the point. -2.01e+11. In the year 1995, what is the difference between the Imports of Barbados and Imports of Swaziland?
Offer a terse response. -9.63e+09. In the year 1995, what is the difference between the Imports of Chad and Imports of Rwanda?
Offer a very short reply. 9.19e+11. In the year 1995, what is the difference between the Imports of Chad and Imports of Swaziland?
Ensure brevity in your answer.  1.11e+12. In the year 1995, what is the difference between the Imports of Rwanda and Imports of Swaziland?
Give a very brief answer. 1.91e+11. In the year 1996, what is the difference between the Imports in Barbados and Imports in Chad?
Provide a succinct answer. -9.85e+11. In the year 1996, what is the difference between the Imports in Barbados and Imports in Rwanda?
Keep it short and to the point. -2.08e+11. In the year 1996, what is the difference between the Imports in Barbados and Imports in Swaziland?
Ensure brevity in your answer.  -9.96e+09. In the year 1996, what is the difference between the Imports in Chad and Imports in Rwanda?
Offer a very short reply. 7.77e+11. In the year 1996, what is the difference between the Imports in Chad and Imports in Swaziland?
Your answer should be compact. 9.75e+11. In the year 1996, what is the difference between the Imports in Rwanda and Imports in Swaziland?
Your answer should be very brief. 1.98e+11. In the year 1997, what is the difference between the Imports of Barbados and Imports of Chad?
Your response must be concise. -1.10e+12. In the year 1997, what is the difference between the Imports in Barbados and Imports in Rwanda?
Make the answer very short. -2.89e+11. In the year 1997, what is the difference between the Imports in Barbados and Imports in Swaziland?
Keep it short and to the point. -1.07e+1. In the year 1997, what is the difference between the Imports in Chad and Imports in Rwanda?
Provide a succinct answer. 8.12e+11. In the year 1997, what is the difference between the Imports in Chad and Imports in Swaziland?
Provide a short and direct response. 1.09e+12. In the year 1997, what is the difference between the Imports of Rwanda and Imports of Swaziland?
Give a very brief answer. 2.78e+11. What is the ratio of the Imports in Barbados in 1990 to that in 1991?
Offer a terse response. 0.76. What is the ratio of the Imports in Chad in 1990 to that in 1991?
Offer a very short reply. 1.08. What is the ratio of the Imports in Rwanda in 1990 to that in 1991?
Your response must be concise. 0.54. What is the ratio of the Imports in Swaziland in 1990 to that in 1991?
Your answer should be very brief. 0.92. What is the ratio of the Imports of Barbados in 1990 to that in 1992?
Offer a very short reply. 1.34. What is the ratio of the Imports of Chad in 1990 to that in 1992?
Your answer should be compact. 1.09. What is the ratio of the Imports of Rwanda in 1990 to that in 1992?
Provide a short and direct response. 0.53. What is the ratio of the Imports of Swaziland in 1990 to that in 1992?
Offer a terse response. 0.79. What is the ratio of the Imports of Barbados in 1990 to that in 1993?
Provide a succinct answer. 1.18. What is the ratio of the Imports in Chad in 1990 to that in 1993?
Your answer should be very brief. 1.14. What is the ratio of the Imports of Rwanda in 1990 to that in 1993?
Provide a short and direct response. 0.45. What is the ratio of the Imports of Swaziland in 1990 to that in 1993?
Ensure brevity in your answer.  0.7. What is the ratio of the Imports in Barbados in 1990 to that in 1994?
Give a very brief answer. 0.81. What is the ratio of the Imports in Chad in 1990 to that in 1994?
Provide a succinct answer. 1.28. What is the ratio of the Imports in Rwanda in 1990 to that in 1994?
Give a very brief answer. 0.4. What is the ratio of the Imports in Swaziland in 1990 to that in 1994?
Your answer should be compact. 0.73. What is the ratio of the Imports of Barbados in 1990 to that in 1995?
Give a very brief answer. 0.73. What is the ratio of the Imports of Chad in 1990 to that in 1995?
Offer a very short reply. 1.31. What is the ratio of the Imports in Rwanda in 1990 to that in 1995?
Your response must be concise. 0.62. What is the ratio of the Imports of Swaziland in 1990 to that in 1995?
Ensure brevity in your answer.  0.66. What is the ratio of the Imports of Barbados in 1990 to that in 1996?
Ensure brevity in your answer.  0.7. What is the ratio of the Imports in Chad in 1990 to that in 1996?
Ensure brevity in your answer.  1.49. What is the ratio of the Imports of Rwanda in 1990 to that in 1996?
Keep it short and to the point. 0.6. What is the ratio of the Imports of Swaziland in 1990 to that in 1996?
Offer a terse response. 0.63. What is the ratio of the Imports in Barbados in 1990 to that in 1997?
Keep it short and to the point. 0.57. What is the ratio of the Imports of Chad in 1990 to that in 1997?
Your answer should be very brief. 1.33. What is the ratio of the Imports of Rwanda in 1990 to that in 1997?
Keep it short and to the point. 0.43. What is the ratio of the Imports of Swaziland in 1990 to that in 1997?
Offer a terse response. 0.58. What is the ratio of the Imports of Barbados in 1991 to that in 1992?
Keep it short and to the point. 1.77. What is the ratio of the Imports of Chad in 1991 to that in 1992?
Give a very brief answer. 1.01. What is the ratio of the Imports in Rwanda in 1991 to that in 1992?
Provide a short and direct response. 0.97. What is the ratio of the Imports of Swaziland in 1991 to that in 1992?
Provide a short and direct response. 0.85. What is the ratio of the Imports of Barbados in 1991 to that in 1993?
Give a very brief answer. 1.55. What is the ratio of the Imports of Chad in 1991 to that in 1993?
Provide a succinct answer. 1.06. What is the ratio of the Imports in Rwanda in 1991 to that in 1993?
Your response must be concise. 0.84. What is the ratio of the Imports of Swaziland in 1991 to that in 1993?
Keep it short and to the point. 0.76. What is the ratio of the Imports of Barbados in 1991 to that in 1994?
Your answer should be very brief. 1.07. What is the ratio of the Imports of Chad in 1991 to that in 1994?
Your answer should be very brief. 1.19. What is the ratio of the Imports in Rwanda in 1991 to that in 1994?
Give a very brief answer. 0.74. What is the ratio of the Imports of Swaziland in 1991 to that in 1994?
Offer a terse response. 0.79. What is the ratio of the Imports in Barbados in 1991 to that in 1995?
Offer a terse response. 0.96. What is the ratio of the Imports in Chad in 1991 to that in 1995?
Your answer should be compact. 1.22. What is the ratio of the Imports of Rwanda in 1991 to that in 1995?
Give a very brief answer. 1.14. What is the ratio of the Imports of Swaziland in 1991 to that in 1995?
Make the answer very short. 0.71. What is the ratio of the Imports of Barbados in 1991 to that in 1996?
Keep it short and to the point. 0.93. What is the ratio of the Imports in Chad in 1991 to that in 1996?
Your answer should be compact. 1.38. What is the ratio of the Imports in Rwanda in 1991 to that in 1996?
Provide a succinct answer. 1.1. What is the ratio of the Imports of Swaziland in 1991 to that in 1996?
Ensure brevity in your answer.  0.69. What is the ratio of the Imports of Barbados in 1991 to that in 1997?
Your answer should be very brief. 0.75. What is the ratio of the Imports of Chad in 1991 to that in 1997?
Make the answer very short. 1.24. What is the ratio of the Imports of Rwanda in 1991 to that in 1997?
Your response must be concise. 0.79. What is the ratio of the Imports in Swaziland in 1991 to that in 1997?
Give a very brief answer. 0.63. What is the ratio of the Imports of Barbados in 1992 to that in 1993?
Your response must be concise. 0.88. What is the ratio of the Imports in Chad in 1992 to that in 1993?
Offer a very short reply. 1.04. What is the ratio of the Imports in Rwanda in 1992 to that in 1993?
Keep it short and to the point. 0.86. What is the ratio of the Imports in Swaziland in 1992 to that in 1993?
Keep it short and to the point. 0.9. What is the ratio of the Imports of Barbados in 1992 to that in 1994?
Your answer should be compact. 0.6. What is the ratio of the Imports in Chad in 1992 to that in 1994?
Provide a short and direct response. 1.17. What is the ratio of the Imports in Rwanda in 1992 to that in 1994?
Provide a short and direct response. 0.76. What is the ratio of the Imports of Swaziland in 1992 to that in 1994?
Ensure brevity in your answer.  0.93. What is the ratio of the Imports of Barbados in 1992 to that in 1995?
Your answer should be very brief. 0.54. What is the ratio of the Imports of Chad in 1992 to that in 1995?
Your answer should be compact. 1.2. What is the ratio of the Imports of Rwanda in 1992 to that in 1995?
Ensure brevity in your answer.  1.17. What is the ratio of the Imports of Swaziland in 1992 to that in 1995?
Your response must be concise. 0.83. What is the ratio of the Imports of Barbados in 1992 to that in 1996?
Provide a succinct answer. 0.52. What is the ratio of the Imports of Chad in 1992 to that in 1996?
Provide a short and direct response. 1.36. What is the ratio of the Imports in Rwanda in 1992 to that in 1996?
Give a very brief answer. 1.13. What is the ratio of the Imports in Swaziland in 1992 to that in 1996?
Provide a succinct answer. 0.8. What is the ratio of the Imports in Barbados in 1992 to that in 1997?
Your response must be concise. 0.42. What is the ratio of the Imports in Chad in 1992 to that in 1997?
Ensure brevity in your answer.  1.22. What is the ratio of the Imports in Rwanda in 1992 to that in 1997?
Ensure brevity in your answer.  0.81. What is the ratio of the Imports in Swaziland in 1992 to that in 1997?
Offer a terse response. 0.74. What is the ratio of the Imports of Barbados in 1993 to that in 1994?
Offer a very short reply. 0.69. What is the ratio of the Imports of Chad in 1993 to that in 1994?
Ensure brevity in your answer.  1.12. What is the ratio of the Imports in Rwanda in 1993 to that in 1994?
Provide a succinct answer. 0.89. What is the ratio of the Imports in Swaziland in 1993 to that in 1994?
Provide a short and direct response. 1.03. What is the ratio of the Imports in Barbados in 1993 to that in 1995?
Offer a terse response. 0.62. What is the ratio of the Imports of Chad in 1993 to that in 1995?
Your answer should be compact. 1.15. What is the ratio of the Imports in Rwanda in 1993 to that in 1995?
Keep it short and to the point. 1.36. What is the ratio of the Imports of Swaziland in 1993 to that in 1995?
Provide a succinct answer. 0.93. What is the ratio of the Imports of Barbados in 1993 to that in 1996?
Your answer should be compact. 0.6. What is the ratio of the Imports in Chad in 1993 to that in 1996?
Your answer should be compact. 1.3. What is the ratio of the Imports of Rwanda in 1993 to that in 1996?
Make the answer very short. 1.32. What is the ratio of the Imports in Swaziland in 1993 to that in 1996?
Ensure brevity in your answer.  0.9. What is the ratio of the Imports in Barbados in 1993 to that in 1997?
Offer a terse response. 0.48. What is the ratio of the Imports of Chad in 1993 to that in 1997?
Provide a succinct answer. 1.17. What is the ratio of the Imports in Rwanda in 1993 to that in 1997?
Give a very brief answer. 0.95. What is the ratio of the Imports in Swaziland in 1993 to that in 1997?
Provide a short and direct response. 0.83. What is the ratio of the Imports of Barbados in 1994 to that in 1995?
Give a very brief answer. 0.9. What is the ratio of the Imports in Chad in 1994 to that in 1995?
Make the answer very short. 1.02. What is the ratio of the Imports in Rwanda in 1994 to that in 1995?
Make the answer very short. 1.54. What is the ratio of the Imports in Swaziland in 1994 to that in 1995?
Provide a short and direct response. 0.9. What is the ratio of the Imports of Barbados in 1994 to that in 1996?
Offer a terse response. 0.87. What is the ratio of the Imports in Chad in 1994 to that in 1996?
Offer a terse response. 1.16. What is the ratio of the Imports of Rwanda in 1994 to that in 1996?
Your response must be concise. 1.49. What is the ratio of the Imports of Swaziland in 1994 to that in 1996?
Your answer should be very brief. 0.87. What is the ratio of the Imports in Barbados in 1994 to that in 1997?
Ensure brevity in your answer.  0.7. What is the ratio of the Imports in Rwanda in 1994 to that in 1997?
Keep it short and to the point. 1.07. What is the ratio of the Imports of Swaziland in 1994 to that in 1997?
Provide a short and direct response. 0.8. What is the ratio of the Imports in Barbados in 1995 to that in 1996?
Your answer should be compact. 0.96. What is the ratio of the Imports of Chad in 1995 to that in 1996?
Offer a terse response. 1.14. What is the ratio of the Imports in Rwanda in 1995 to that in 1996?
Offer a terse response. 0.97. What is the ratio of the Imports in Swaziland in 1995 to that in 1996?
Give a very brief answer. 0.97. What is the ratio of the Imports of Barbados in 1995 to that in 1997?
Your response must be concise. 0.78. What is the ratio of the Imports in Chad in 1995 to that in 1997?
Provide a short and direct response. 1.02. What is the ratio of the Imports of Rwanda in 1995 to that in 1997?
Keep it short and to the point. 0.7. What is the ratio of the Imports in Swaziland in 1995 to that in 1997?
Offer a terse response. 0.89. What is the ratio of the Imports in Barbados in 1996 to that in 1997?
Provide a short and direct response. 0.81. What is the ratio of the Imports in Chad in 1996 to that in 1997?
Your answer should be compact. 0.89. What is the ratio of the Imports of Rwanda in 1996 to that in 1997?
Ensure brevity in your answer.  0.72. What is the ratio of the Imports in Swaziland in 1996 to that in 1997?
Your answer should be compact. 0.92. What is the difference between the highest and the second highest Imports in Barbados?
Make the answer very short. 1.30e+08. What is the difference between the highest and the second highest Imports of Chad?
Ensure brevity in your answer.  1.04e+11. What is the difference between the highest and the second highest Imports of Rwanda?
Keep it short and to the point. 2.04e+1. What is the difference between the highest and the second highest Imports in Swaziland?
Ensure brevity in your answer.  8.96e+08. What is the difference between the highest and the lowest Imports in Barbados?
Your response must be concise. 3.92e+08. What is the difference between the highest and the lowest Imports of Chad?
Provide a succinct answer. 4.80e+11. What is the difference between the highest and the lowest Imports of Rwanda?
Your answer should be very brief. 1.86e+11. What is the difference between the highest and the lowest Imports of Swaziland?
Ensure brevity in your answer.  4.75e+09. 